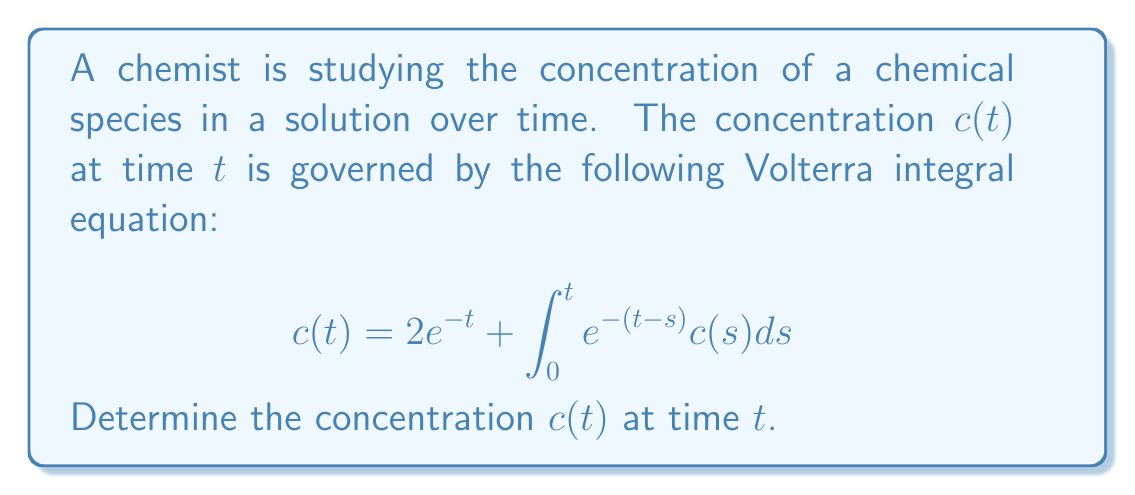Help me with this question. To solve this Volterra integral equation, we'll use the Laplace transform method:

1) Let $C(s)$ be the Laplace transform of $c(t)$. Take the Laplace transform of both sides:

   $$\mathcal{L}\{c(t)\} = \mathcal{L}\{2e^{-t}\} + \mathcal{L}\{\int_0^t e^{-(t-s)}c(s)ds\}$$

2) Using Laplace transform properties:

   $$C(s) = \frac{2}{s+1} + \mathcal{L}\{e^{-t}\} \cdot C(s)$$

3) Simplify:

   $$C(s) = \frac{2}{s+1} + \frac{1}{s+1}C(s)$$

4) Solve for $C(s)$:

   $$C(s) - \frac{1}{s+1}C(s) = \frac{2}{s+1}$$
   
   $$C(s)\left(1 - \frac{1}{s+1}\right) = \frac{2}{s+1}$$
   
   $$C(s)\left(\frac{s}{s+1}\right) = \frac{2}{s+1}$$
   
   $$C(s) = \frac{2}{s}$$

5) Take the inverse Laplace transform:

   $$c(t) = \mathcal{L}^{-1}\{\frac{2}{s}\} = 2$$

Thus, the concentration $c(t)$ is constant and equal to 2 for all $t \geq 0$.
Answer: $c(t) = 2$ 